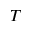<formula> <loc_0><loc_0><loc_500><loc_500>T</formula> 